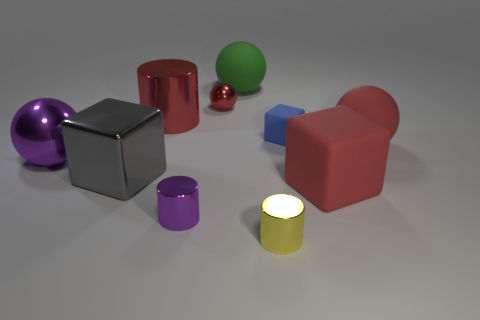What can you infer about the material of the objects based on their appearance? From the reflections and highlights on the surfaces, we can infer that most of the objects have a smooth and shiny texture, which suggests they are made of materials like plastic or polished metal. The glowing yellow cylinder may indicate that it is luminescent or has a light source inside it, which could imply a translucent or glass-like material.  Are there any signs that this image could have been computer-generated? Yes, there are indicators that this might be a computer-generated image. The perfection and uniformity of the objects' shapes, the cleanliness of the environment, and the precise lighting and shadows may not typically occur in a natural setting. These aspects suggest the scene could be a result of 3D rendering software. 